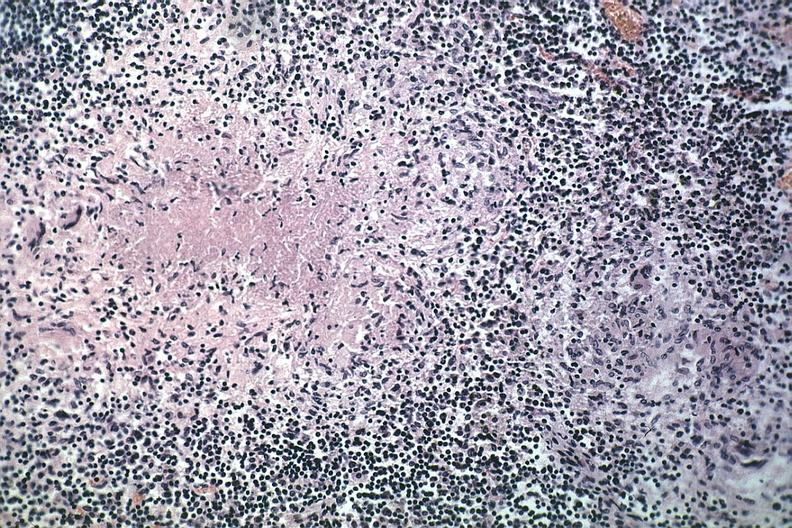does marfans syndrome show typical area of caseous necrosis with nearby early granuloma quite good source unknown?
Answer the question using a single word or phrase. No 